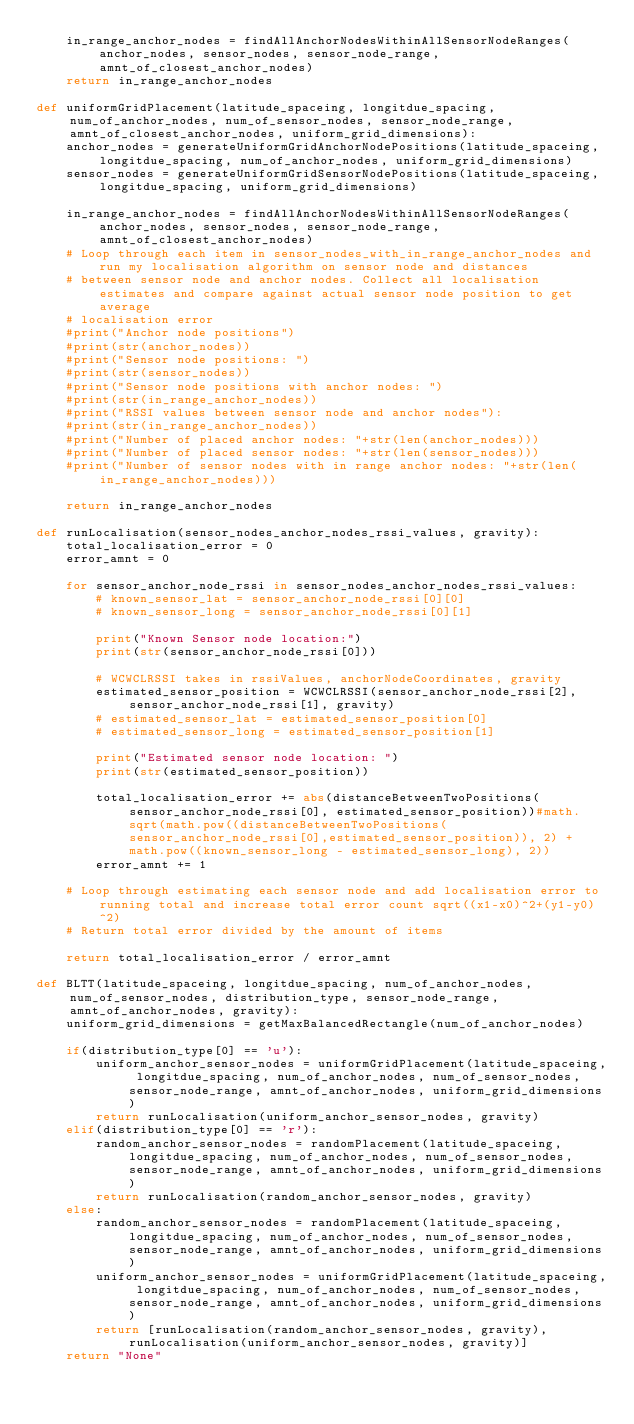<code> <loc_0><loc_0><loc_500><loc_500><_Python_>    in_range_anchor_nodes = findAllAnchorNodesWithinAllSensorNodeRanges(anchor_nodes, sensor_nodes, sensor_node_range, amnt_of_closest_anchor_nodes)
    return in_range_anchor_nodes

def uniformGridPlacement(latitude_spaceing, longitdue_spacing, num_of_anchor_nodes, num_of_sensor_nodes, sensor_node_range, amnt_of_closest_anchor_nodes, uniform_grid_dimensions):
    anchor_nodes = generateUniformGridAnchorNodePositions(latitude_spaceing, longitdue_spacing, num_of_anchor_nodes, uniform_grid_dimensions)
    sensor_nodes = generateUniformGridSensorNodePositions(latitude_spaceing, longitdue_spacing, uniform_grid_dimensions)

    in_range_anchor_nodes = findAllAnchorNodesWithinAllSensorNodeRanges(anchor_nodes, sensor_nodes, sensor_node_range, amnt_of_closest_anchor_nodes)
    # Loop through each item in sensor_nodes_with_in_range_anchor_nodes and run my localisation algorithm on sensor node and distances
    # between sensor node and anchor nodes. Collect all localisation estimates and compare against actual sensor node position to get average
    # localisation error
    #print("Anchor node positions")
    #print(str(anchor_nodes))
    #print("Sensor node positions: ")
    #print(str(sensor_nodes))
    #print("Sensor node positions with anchor nodes: ")
    #print(str(in_range_anchor_nodes))
    #print("RSSI values between sensor node and anchor nodes"):
    #print(str(in_range_anchor_nodes))
    #print("Number of placed anchor nodes: "+str(len(anchor_nodes)))
    #print("Number of placed sensor nodes: "+str(len(sensor_nodes)))
    #print("Number of sensor nodes with in range anchor nodes: "+str(len(in_range_anchor_nodes)))

    return in_range_anchor_nodes

def runLocalisation(sensor_nodes_anchor_nodes_rssi_values, gravity):
    total_localisation_error = 0
    error_amnt = 0

    for sensor_anchor_node_rssi in sensor_nodes_anchor_nodes_rssi_values:
        # known_sensor_lat = sensor_anchor_node_rssi[0][0]
        # known_sensor_long = sensor_anchor_node_rssi[0][1]

        print("Known Sensor node location:")
        print(str(sensor_anchor_node_rssi[0]))

        # WCWCLRSSI takes in rssiValues, anchorNodeCoordinates, gravity
        estimated_sensor_position = WCWCLRSSI(sensor_anchor_node_rssi[2], sensor_anchor_node_rssi[1], gravity)
        # estimated_sensor_lat = estimated_sensor_position[0]
        # estimated_sensor_long = estimated_sensor_position[1]

        print("Estimated sensor node location: ")
        print(str(estimated_sensor_position))

        total_localisation_error += abs(distanceBetweenTwoPositions(sensor_anchor_node_rssi[0], estimated_sensor_position))#math.sqrt(math.pow((distanceBetweenTwoPositions(sensor_anchor_node_rssi[0],estimated_sensor_position)), 2) + math.pow((known_sensor_long - estimated_sensor_long), 2))  
        error_amnt += 1
    
    # Loop through estimating each sensor node and add localisation error to running total and increase total error count sqrt((x1-x0)^2+(y1-y0)^2)
    # Return total error divided by the amount of items

    return total_localisation_error / error_amnt

def BLTT(latitude_spaceing, longitdue_spacing, num_of_anchor_nodes, num_of_sensor_nodes, distribution_type, sensor_node_range, amnt_of_anchor_nodes, gravity):
    uniform_grid_dimensions = getMaxBalancedRectangle(num_of_anchor_nodes)

    if(distribution_type[0] == 'u'):
        uniform_anchor_sensor_nodes = uniformGridPlacement(latitude_spaceing, longitdue_spacing, num_of_anchor_nodes, num_of_sensor_nodes, sensor_node_range, amnt_of_anchor_nodes, uniform_grid_dimensions)
        return runLocalisation(uniform_anchor_sensor_nodes, gravity)
    elif(distribution_type[0] == 'r'):
        random_anchor_sensor_nodes = randomPlacement(latitude_spaceing, longitdue_spacing, num_of_anchor_nodes, num_of_sensor_nodes, sensor_node_range, amnt_of_anchor_nodes, uniform_grid_dimensions)
        return runLocalisation(random_anchor_sensor_nodes, gravity)
    else:
        random_anchor_sensor_nodes = randomPlacement(latitude_spaceing, longitdue_spacing, num_of_anchor_nodes, num_of_sensor_nodes, sensor_node_range, amnt_of_anchor_nodes, uniform_grid_dimensions)
        uniform_anchor_sensor_nodes = uniformGridPlacement(latitude_spaceing, longitdue_spacing, num_of_anchor_nodes, num_of_sensor_nodes, sensor_node_range, amnt_of_anchor_nodes, uniform_grid_dimensions)
        return [runLocalisation(random_anchor_sensor_nodes, gravity), runLocalisation(uniform_anchor_sensor_nodes, gravity)]
    return "None"

</code> 